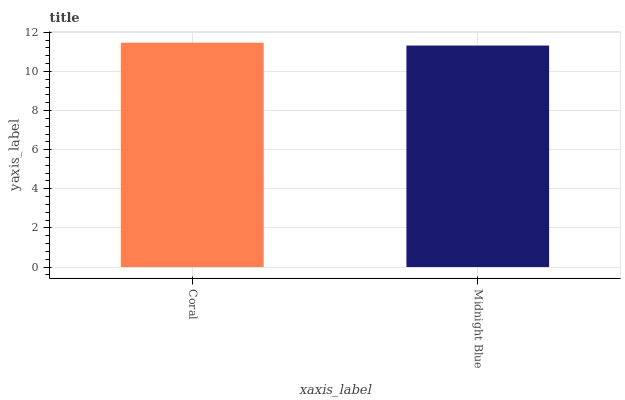Is Midnight Blue the minimum?
Answer yes or no. Yes. Is Coral the maximum?
Answer yes or no. Yes. Is Midnight Blue the maximum?
Answer yes or no. No. Is Coral greater than Midnight Blue?
Answer yes or no. Yes. Is Midnight Blue less than Coral?
Answer yes or no. Yes. Is Midnight Blue greater than Coral?
Answer yes or no. No. Is Coral less than Midnight Blue?
Answer yes or no. No. Is Coral the high median?
Answer yes or no. Yes. Is Midnight Blue the low median?
Answer yes or no. Yes. Is Midnight Blue the high median?
Answer yes or no. No. Is Coral the low median?
Answer yes or no. No. 